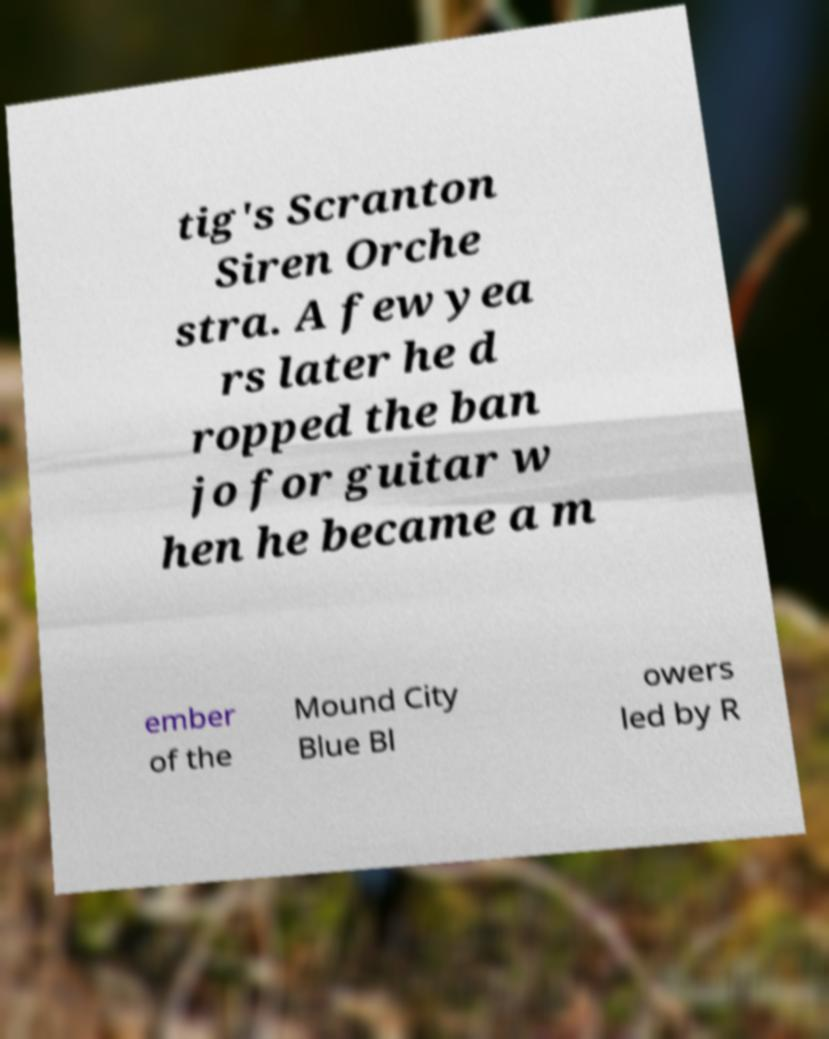Please identify and transcribe the text found in this image. tig's Scranton Siren Orche stra. A few yea rs later he d ropped the ban jo for guitar w hen he became a m ember of the Mound City Blue Bl owers led by R 